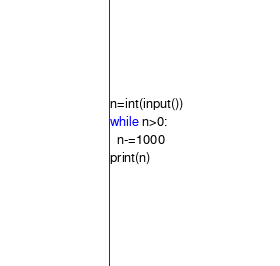<code> <loc_0><loc_0><loc_500><loc_500><_Python_>n=int(input())
while n>0:
  n-=1000
print(n)
</code> 